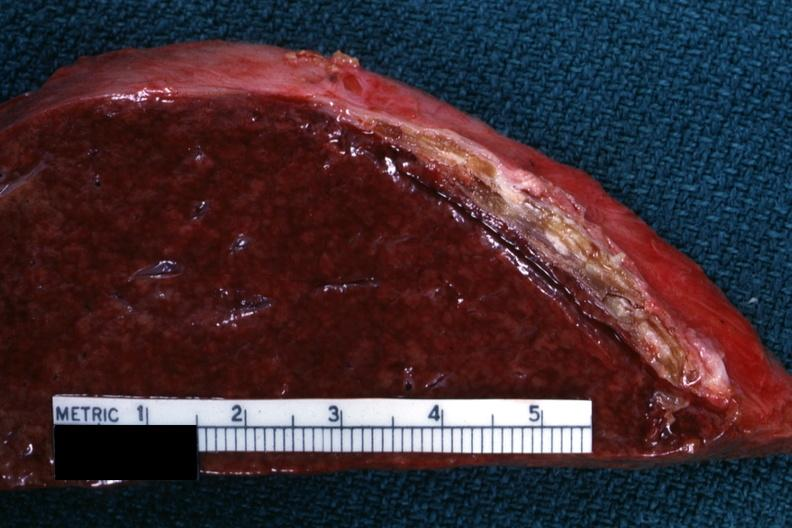s atherosclerosis present?
Answer the question using a single word or phrase. No 